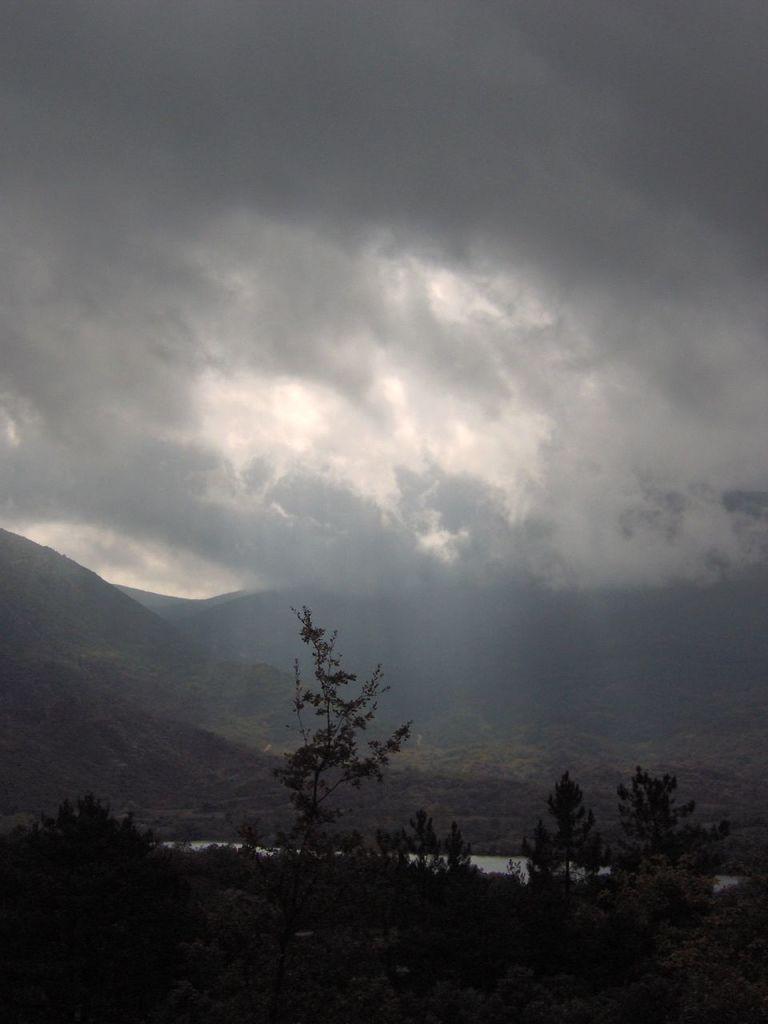Can you describe this image briefly? In the picture we can see some plants and behind it, we can see water surface and behind it, we can see hills covered with grass and plants and in the background we can see a sky with clouds. 